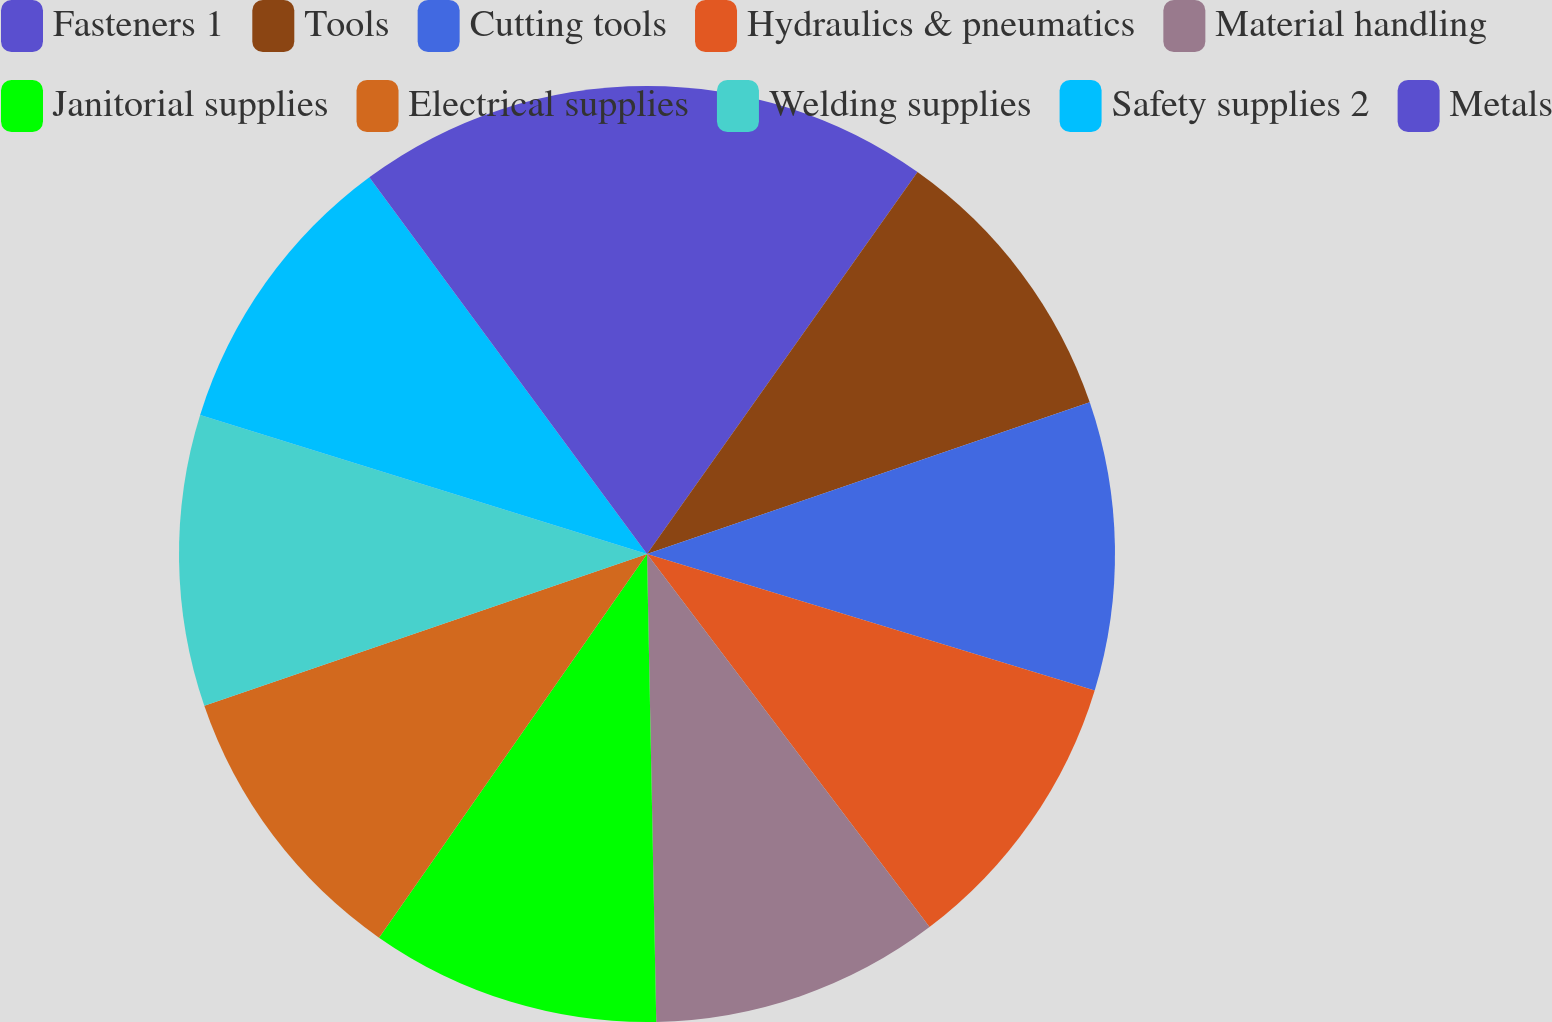Convert chart. <chart><loc_0><loc_0><loc_500><loc_500><pie_chart><fcel>Fasteners 1<fcel>Tools<fcel>Cutting tools<fcel>Hydraulics & pneumatics<fcel>Material handling<fcel>Janitorial supplies<fcel>Electrical supplies<fcel>Welding supplies<fcel>Safety supplies 2<fcel>Metals<nl><fcel>9.81%<fcel>9.94%<fcel>9.96%<fcel>9.98%<fcel>10.0%<fcel>10.02%<fcel>10.04%<fcel>10.06%<fcel>10.09%<fcel>10.11%<nl></chart> 